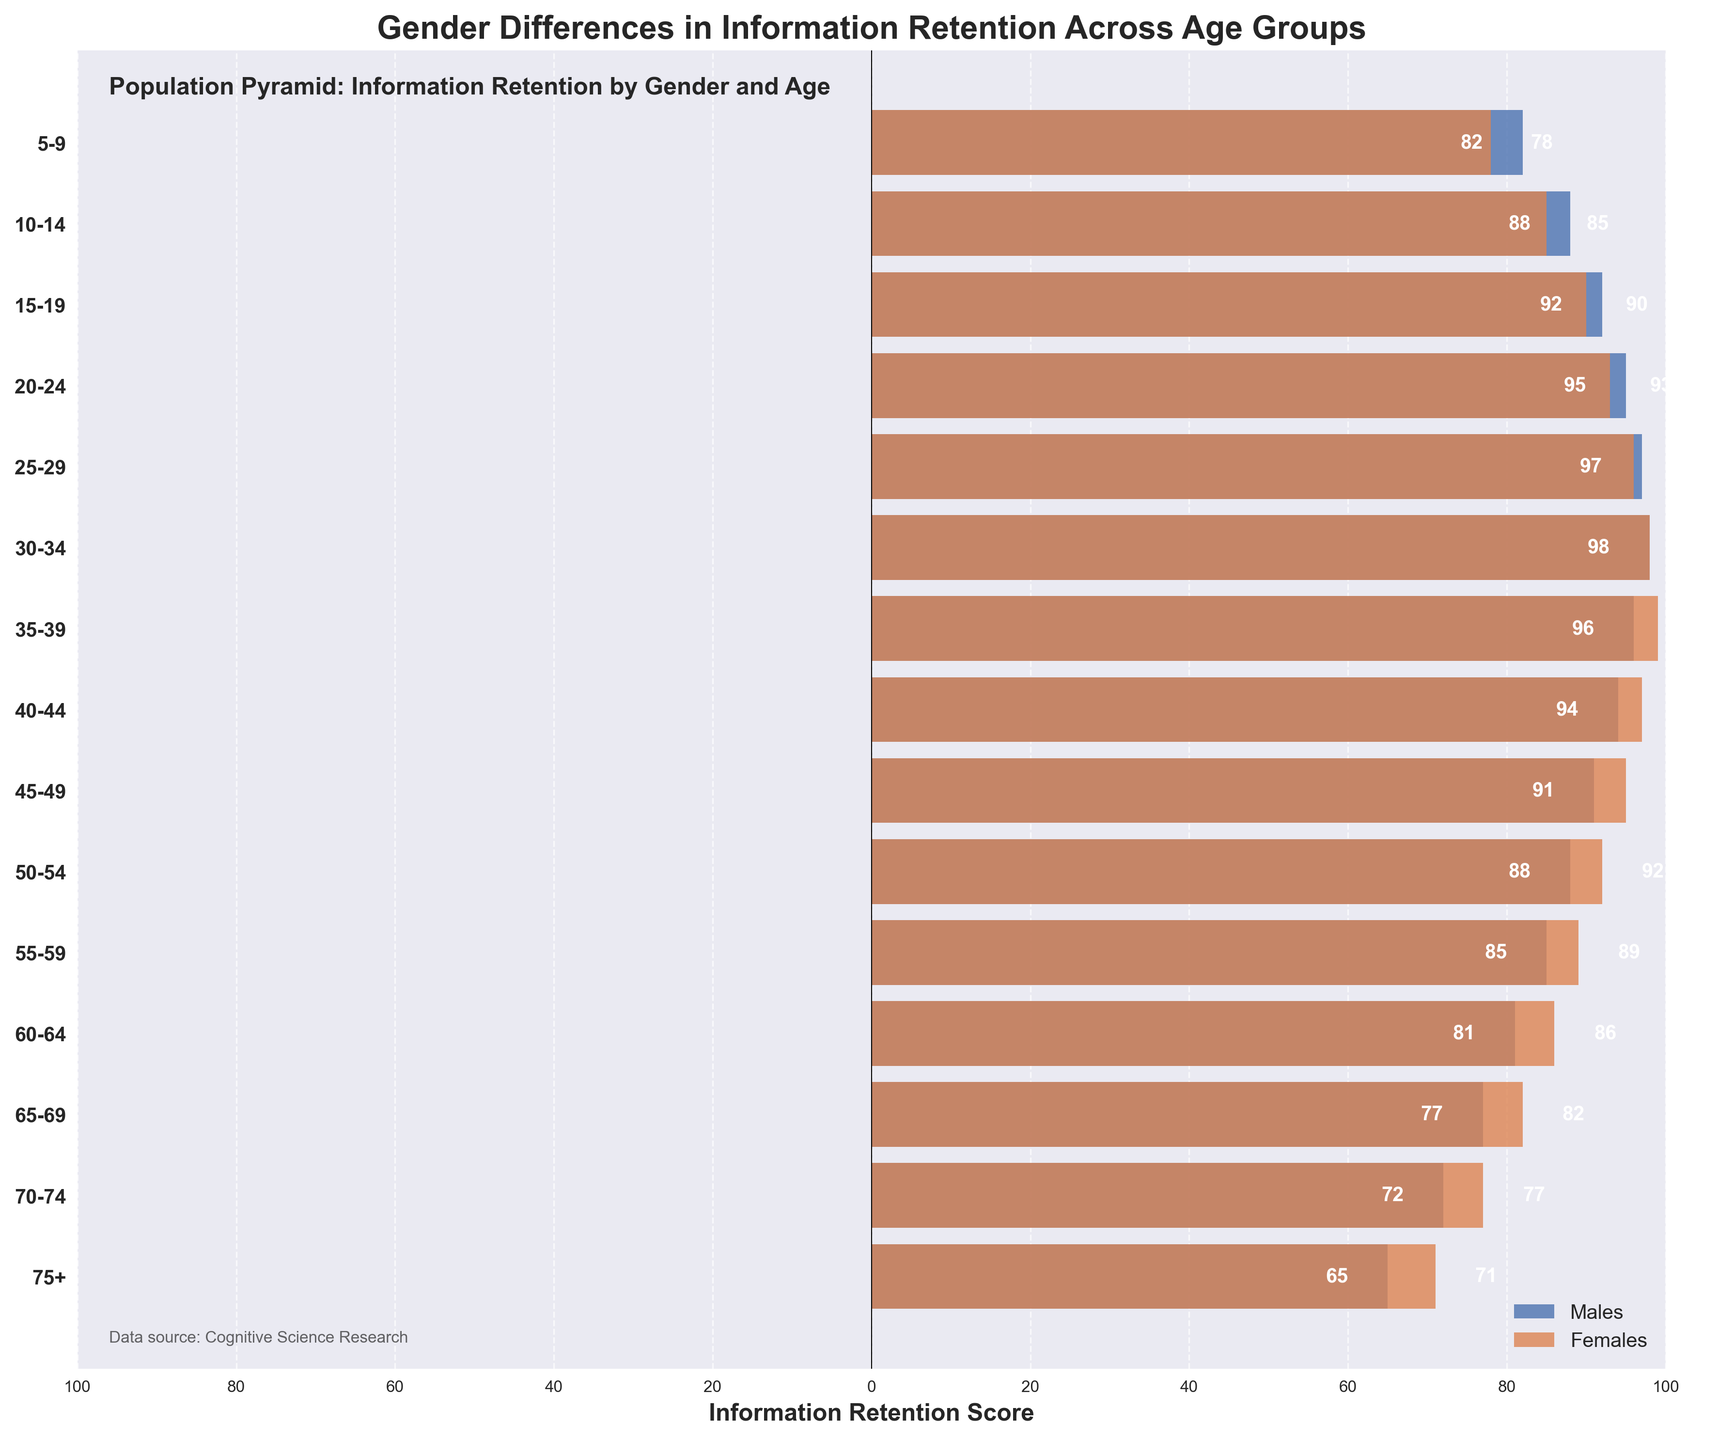What is the title of the figure? The title of the figure is shown at the top. It reads "Gender Differences in Information Retention Across Age Groups".
Answer: Gender Differences in Information Retention Across Age Groups What is the information retention score for females in the 30-34 age group? The figure shows the scores for both genders along the horizontal bars. The score for females in the 30-34 age group is marked by the bar value highlighted on the right side.
Answer: 98 Are there more males or females with higher information retention in the 10-14 age group? The lengths of the bars indicate the information retention scores. The female bar is slightly longer than the male bar in the 10-14 age group, indicating higher retention.
Answer: Females Which age group has the highest information retention score among males? By examining the lengths of the bars for all age groups, the longest bar on the left indicates the highest retention score for males, which is in the 30-34 age group.
Answer: 30-34 What is the difference in information retention score between males and females in the 75+ age group? The retention score for males is 65 (absolute value) and for females is 71. The difference is calculated as 71 - 65.
Answer: 6 In which age group do males and females have almost equal information retention scores? By comparing the lengths of the bars for each age group, the 30-34 age group shows both bars with nearly equal lengths indicating almost equal retention scores.
Answer: 30-34 How does the information retention score trend differ between males and females as the age group increases from 5-9 to 75+? By observing the lengths of the bars from the youngest to the oldest age group, both trends can be analyzed. Generally, males see a decrease while females see a relatively smaller decrease in retention scores.
Answer: Males: Decreasing, Females: Slightly Decreasing Which gender shows a steadier trend in information retention scores across the age groups? By examining the overall consistency in the lengths of the bars, females display more consistent lengths across various age groups compared to males.
Answer: Females What is the combined score for males and females in the 25-29 age group? Adding the absolute values of information retention scores: for males, it's 97, and for females, it's 96. So, 97 + 96.
Answer: 193 Do males or females generally have higher information retention scores based on this figure? The right side of the figure shows most bars for females being slightly longer than those on the left, indicating relatively higher scores.
Answer: Females 